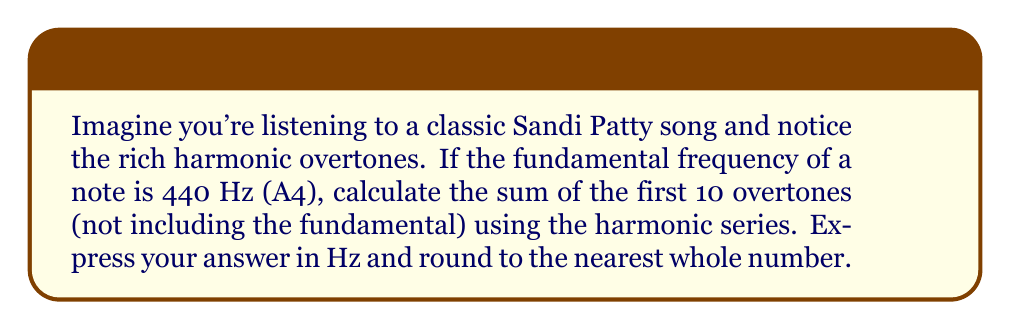What is the answer to this math problem? Let's approach this step-by-step:

1) The harmonic series is represented by:

   $$\sum_{n=1}^{\infty} \frac{1}{n}$$

2) In music, overtones follow this series, but we multiply each term by the fundamental frequency. So for a fundamental of 440 Hz, the nth overtone is:

   $$f_n = 440n \text{ Hz}$$

3) We need to sum the first 10 overtones, not including the fundamental. This means we start at n=2 and go to n=11:

   $$\sum_{n=2}^{11} 440n$$

4) Let's expand this:

   $$440(2 + 3 + 4 + 5 + 6 + 7 + 8 + 9 + 10 + 11)$$

5) The sum of integers from 2 to 11 can be calculated using the arithmetic series formula:

   $$S_n = \frac{n(a_1 + a_n)}{2}$$

   Where n = 10 (number of terms), a₁ = 2 (first term), and a_n = 11 (last term)

6) Plugging in these values:

   $$\frac{10(2 + 11)}{2} = \frac{10(13)}{2} = 65$$

7) Now, we multiply this by 440:

   $$440 * 65 = 28,600 \text{ Hz}$$
Answer: 28,600 Hz 